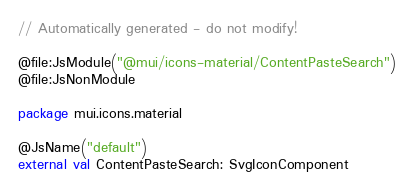Convert code to text. <code><loc_0><loc_0><loc_500><loc_500><_Kotlin_>// Automatically generated - do not modify!

@file:JsModule("@mui/icons-material/ContentPasteSearch")
@file:JsNonModule

package mui.icons.material

@JsName("default")
external val ContentPasteSearch: SvgIconComponent
</code> 